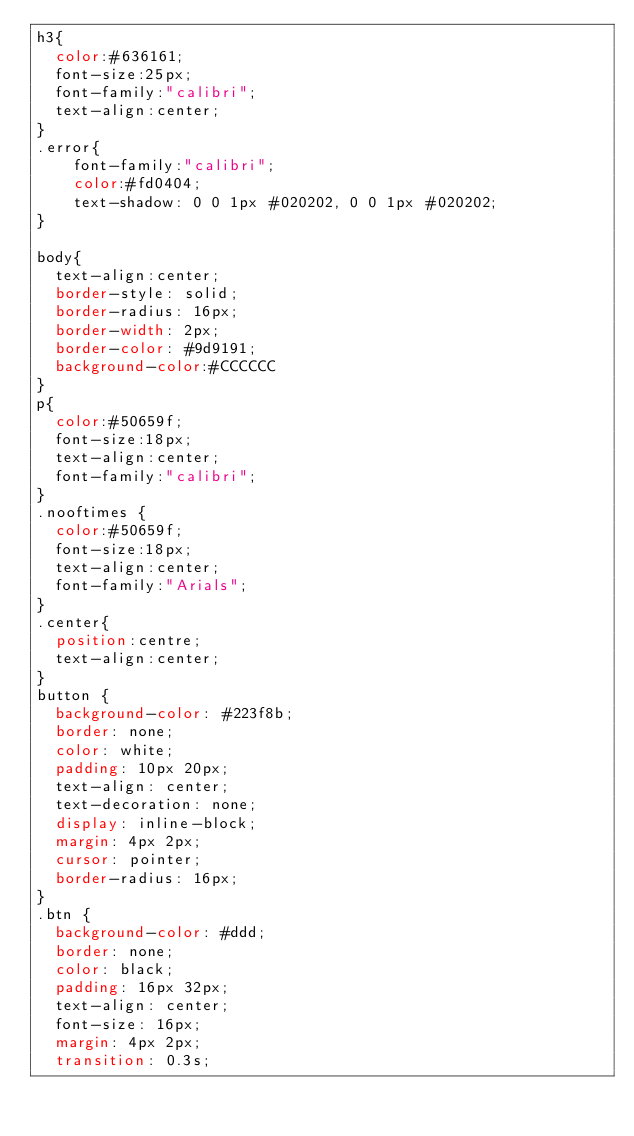<code> <loc_0><loc_0><loc_500><loc_500><_CSS_>h3{
  color:#636161;
  font-size:25px;
  font-family:"calibri";
  text-align:center;
}
.error{
	font-family:"calibri";
	color:#fd0404;
	text-shadow: 0 0 1px #020202, 0 0 1px #020202;
}
	
body{
  text-align:center;
  border-style: solid;
  border-radius: 16px;
  border-width: 2px;
  border-color: #9d9191;
  background-color:#CCCCCC
}
p{
  color:#50659f;
  font-size:18px;
  text-align:center;
  font-family:"calibri";
}
.nooftimes {
  color:#50659f;
  font-size:18px;
  text-align:center;
  font-family:"Arials";
}
.center{
  position:centre;
  text-align:center;
}
button {
  background-color: #223f8b;
  border: none;
  color: white;
  padding: 10px 20px;
  text-align: center;
  text-decoration: none;
  display: inline-block;
  margin: 4px 2px;
  cursor: pointer;
  border-radius: 16px;
}
.btn {
  background-color: #ddd;
  border: none;
  color: black;
  padding: 16px 32px;
  text-align: center;
  font-size: 16px;
  margin: 4px 2px;
  transition: 0.3s;</code> 